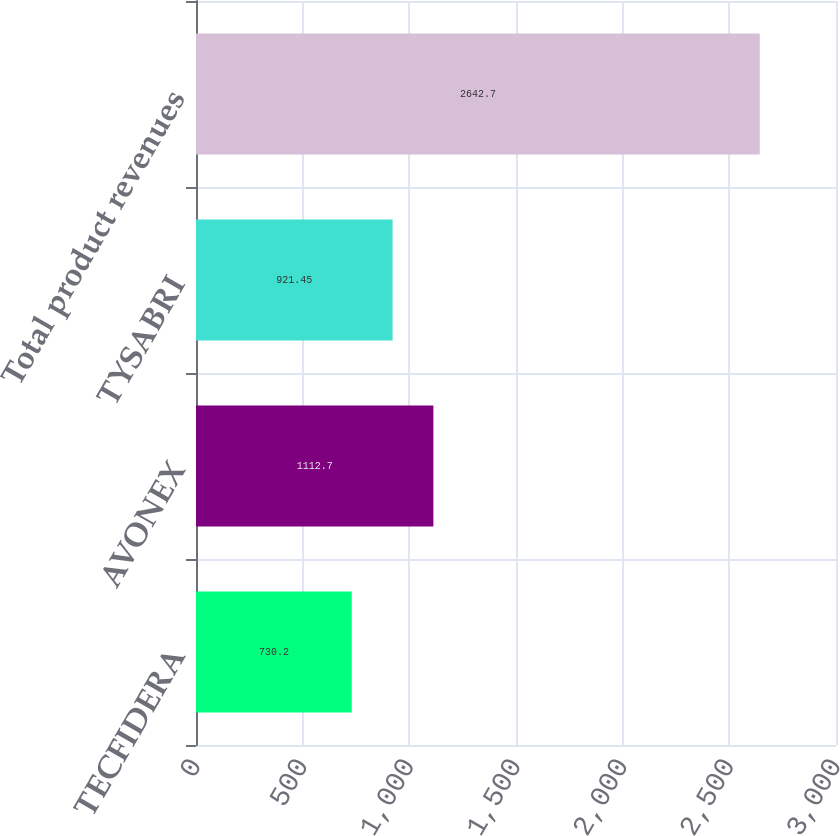Convert chart. <chart><loc_0><loc_0><loc_500><loc_500><bar_chart><fcel>TECFIDERA<fcel>AVONEX<fcel>TYSABRI<fcel>Total product revenues<nl><fcel>730.2<fcel>1112.7<fcel>921.45<fcel>2642.7<nl></chart> 